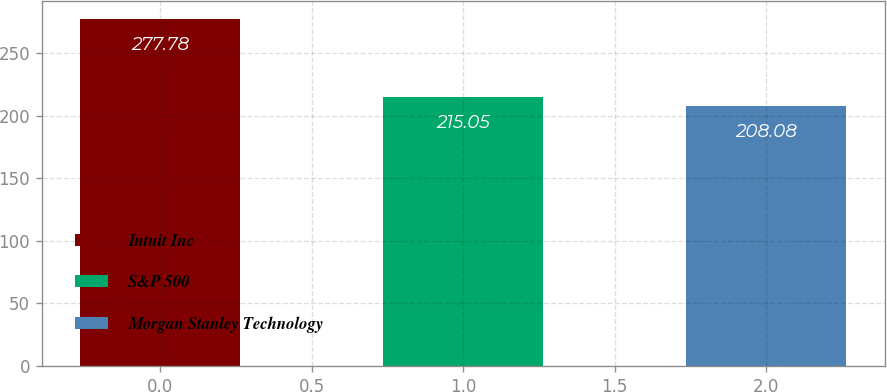Convert chart to OTSL. <chart><loc_0><loc_0><loc_500><loc_500><bar_chart><fcel>Intuit Inc<fcel>S&P 500<fcel>Morgan Stanley Technology<nl><fcel>277.78<fcel>215.05<fcel>208.08<nl></chart> 